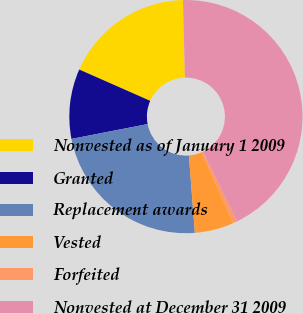Convert chart. <chart><loc_0><loc_0><loc_500><loc_500><pie_chart><fcel>Nonvested as of January 1 2009<fcel>Granted<fcel>Replacement awards<fcel>Vested<fcel>Forfeited<fcel>Nonvested at December 31 2009<nl><fcel>17.98%<fcel>9.68%<fcel>23.16%<fcel>5.42%<fcel>0.57%<fcel>43.19%<nl></chart> 